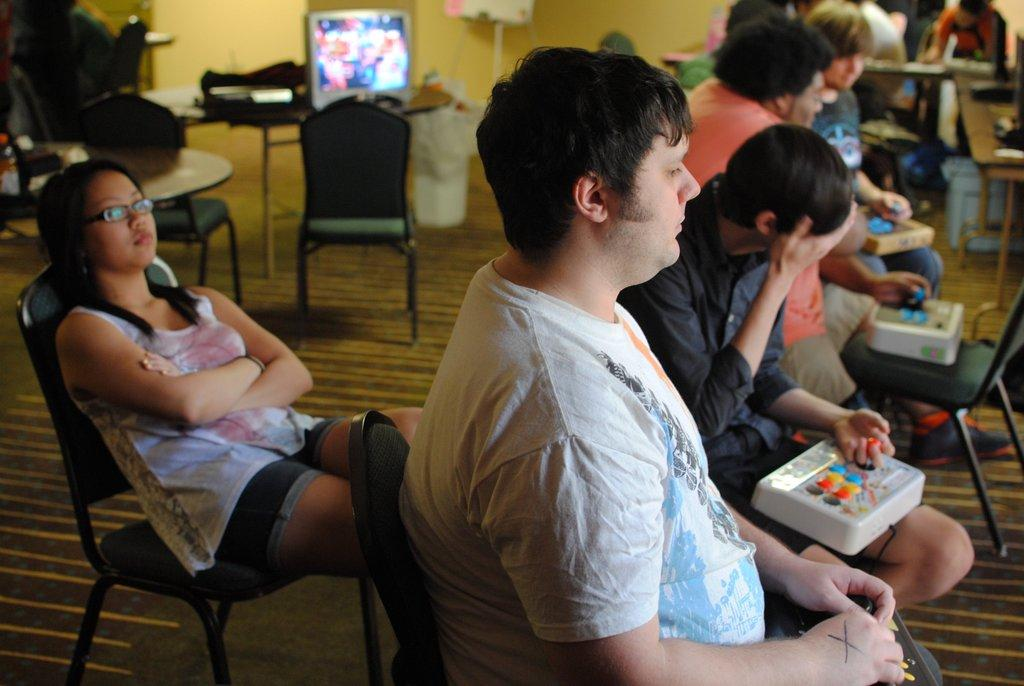Where was the image taken? The image was taken in a room. What furniture is present in the room? There are multiple chairs and a table in the room. What are the people in the image doing? People are sitting on the chairs. Where is the television located in the room? The television is present on top of something, likely a table or stand. On which side of the room is the table located? The table is on the left side of the room. What scent can be smelled in the room from the image? There is no information about scents in the image, so it cannot be determined from the image. --- Facts: 1. There is a person holding a book in the image. 2. The person is sitting on a chair. 3. The chair is in front of a desk. 4. There is a lamp on the desk. 5. The room has a window. Absurd Topics: parrot, ocean, dance Conversation: What is the person in the image holding? The person is holding a book in the image. What is the person's position in the image? The person is sitting on a chair. Where is the chair located in relation to the desk? The chair is in front of a desk. What is present on the desk in the image? There is a lamp on the desk. What can be seen outside the room through the window? The facts do not specify what can be seen outside the room through the window. Reasoning: Let's think step by step in order to produce the conversation. We start by identifying the main subject in the image, which is the person holding a book. Then, we describe the person's position and the furniture they are interacting with, such as the chair and desk. We also mention the lamp on the desk. Finally, we acknowledge the presence of a window in the room but do not make any assumptions about what can be seen outside. Absurd Question/Answer: Can you see a parrot dancing on the ocean in the image? There is no parrot, dancing, or ocean present in the image. 